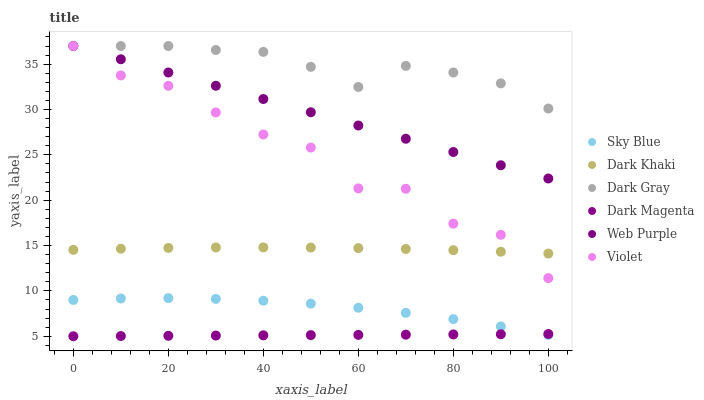Does Dark Magenta have the minimum area under the curve?
Answer yes or no. Yes. Does Dark Gray have the maximum area under the curve?
Answer yes or no. Yes. Does Dark Khaki have the minimum area under the curve?
Answer yes or no. No. Does Dark Khaki have the maximum area under the curve?
Answer yes or no. No. Is Dark Magenta the smoothest?
Answer yes or no. Yes. Is Violet the roughest?
Answer yes or no. Yes. Is Dark Khaki the smoothest?
Answer yes or no. No. Is Dark Khaki the roughest?
Answer yes or no. No. Does Dark Magenta have the lowest value?
Answer yes or no. Yes. Does Dark Khaki have the lowest value?
Answer yes or no. No. Does Violet have the highest value?
Answer yes or no. Yes. Does Dark Khaki have the highest value?
Answer yes or no. No. Is Dark Magenta less than Violet?
Answer yes or no. Yes. Is Dark Khaki greater than Dark Magenta?
Answer yes or no. Yes. Does Web Purple intersect Violet?
Answer yes or no. Yes. Is Web Purple less than Violet?
Answer yes or no. No. Is Web Purple greater than Violet?
Answer yes or no. No. Does Dark Magenta intersect Violet?
Answer yes or no. No. 